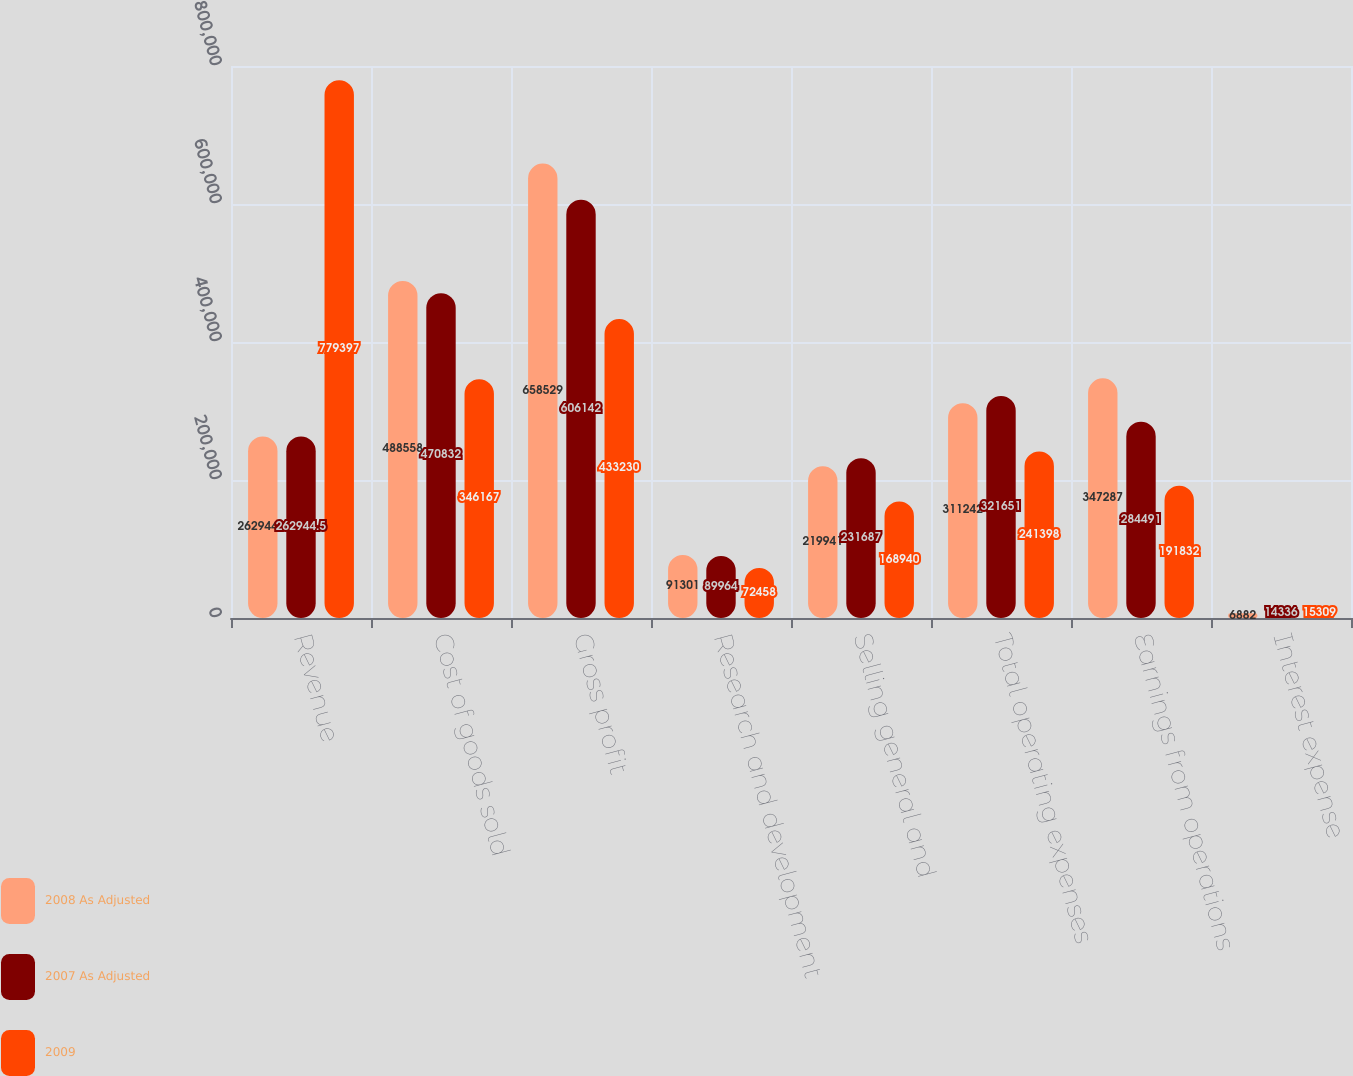Convert chart to OTSL. <chart><loc_0><loc_0><loc_500><loc_500><stacked_bar_chart><ecel><fcel>Revenue<fcel>Cost of goods sold<fcel>Gross profit<fcel>Research and development<fcel>Selling general and<fcel>Total operating expenses<fcel>Earnings from operations<fcel>Interest expense<nl><fcel>2008 As Adjusted<fcel>262944<fcel>488558<fcel>658529<fcel>91301<fcel>219941<fcel>311242<fcel>347287<fcel>6882<nl><fcel>2007 As Adjusted<fcel>262944<fcel>470832<fcel>606142<fcel>89964<fcel>231687<fcel>321651<fcel>284491<fcel>14336<nl><fcel>2009<fcel>779397<fcel>346167<fcel>433230<fcel>72458<fcel>168940<fcel>241398<fcel>191832<fcel>15309<nl></chart> 